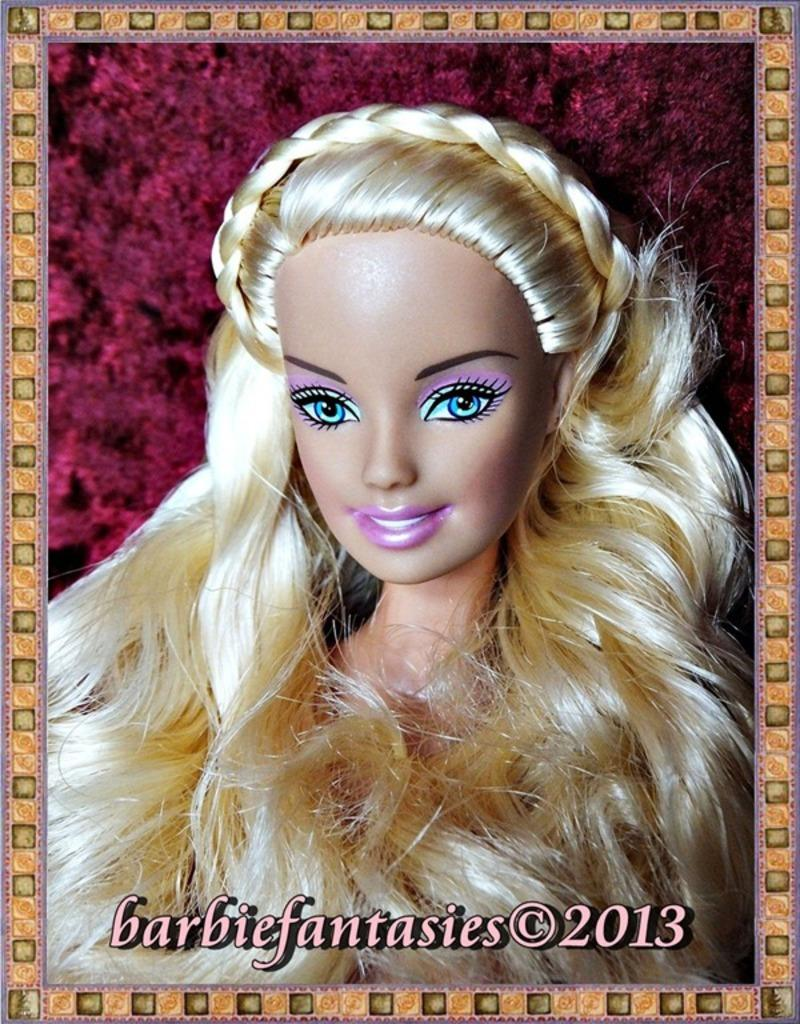What is the main subject of the image? There is a Barbie doll in the image. What color is the background of the image? The background of the image is maroon in color. Is there any additional information or marking on the image? Yes, there is a watermark on the bottom of the image. How many ants can be seen crawling on the Barbie doll in the image? There are no ants present in the image; it only features a Barbie doll and a maroon background. What type of line is used to draw the Barbie doll in the image? The image is a photograph, not a drawing, so there is no line used to draw the Barbie doll. 